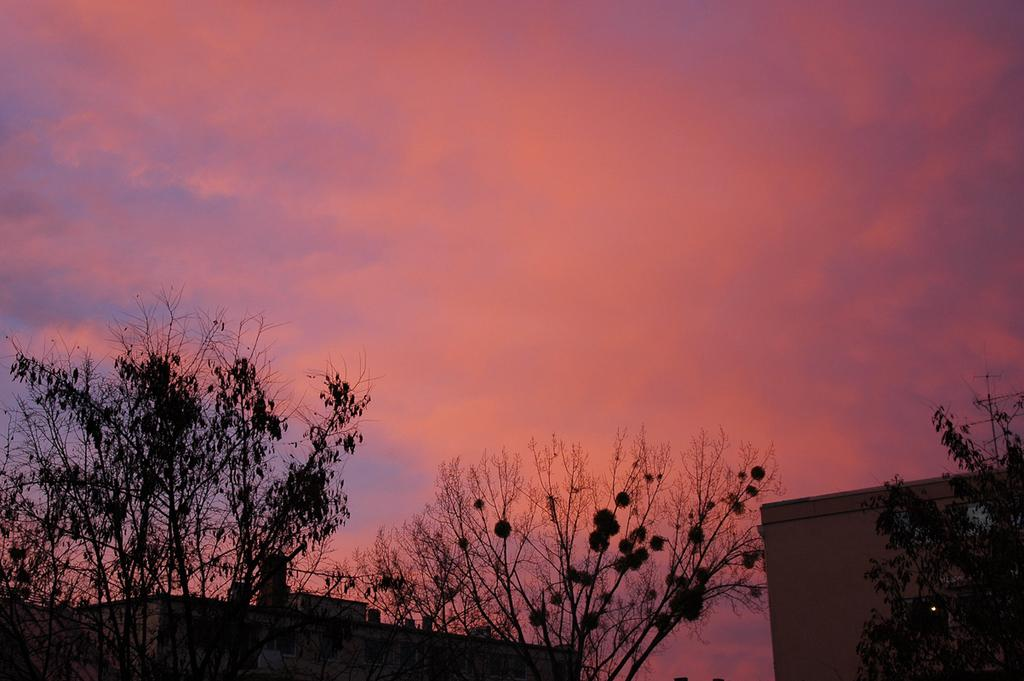What types of structures and vegetation are located at the bottom of the image? There are houses and trees at the bottom of the image. What is visible at the top of the image? The sky is visible at the top of the image. What is the average income of the people living in the houses in the image? There is no information provided about the income of the people living in the houses in the image. What shape is the pail that is visible in the image? There is no pail present in the image. 